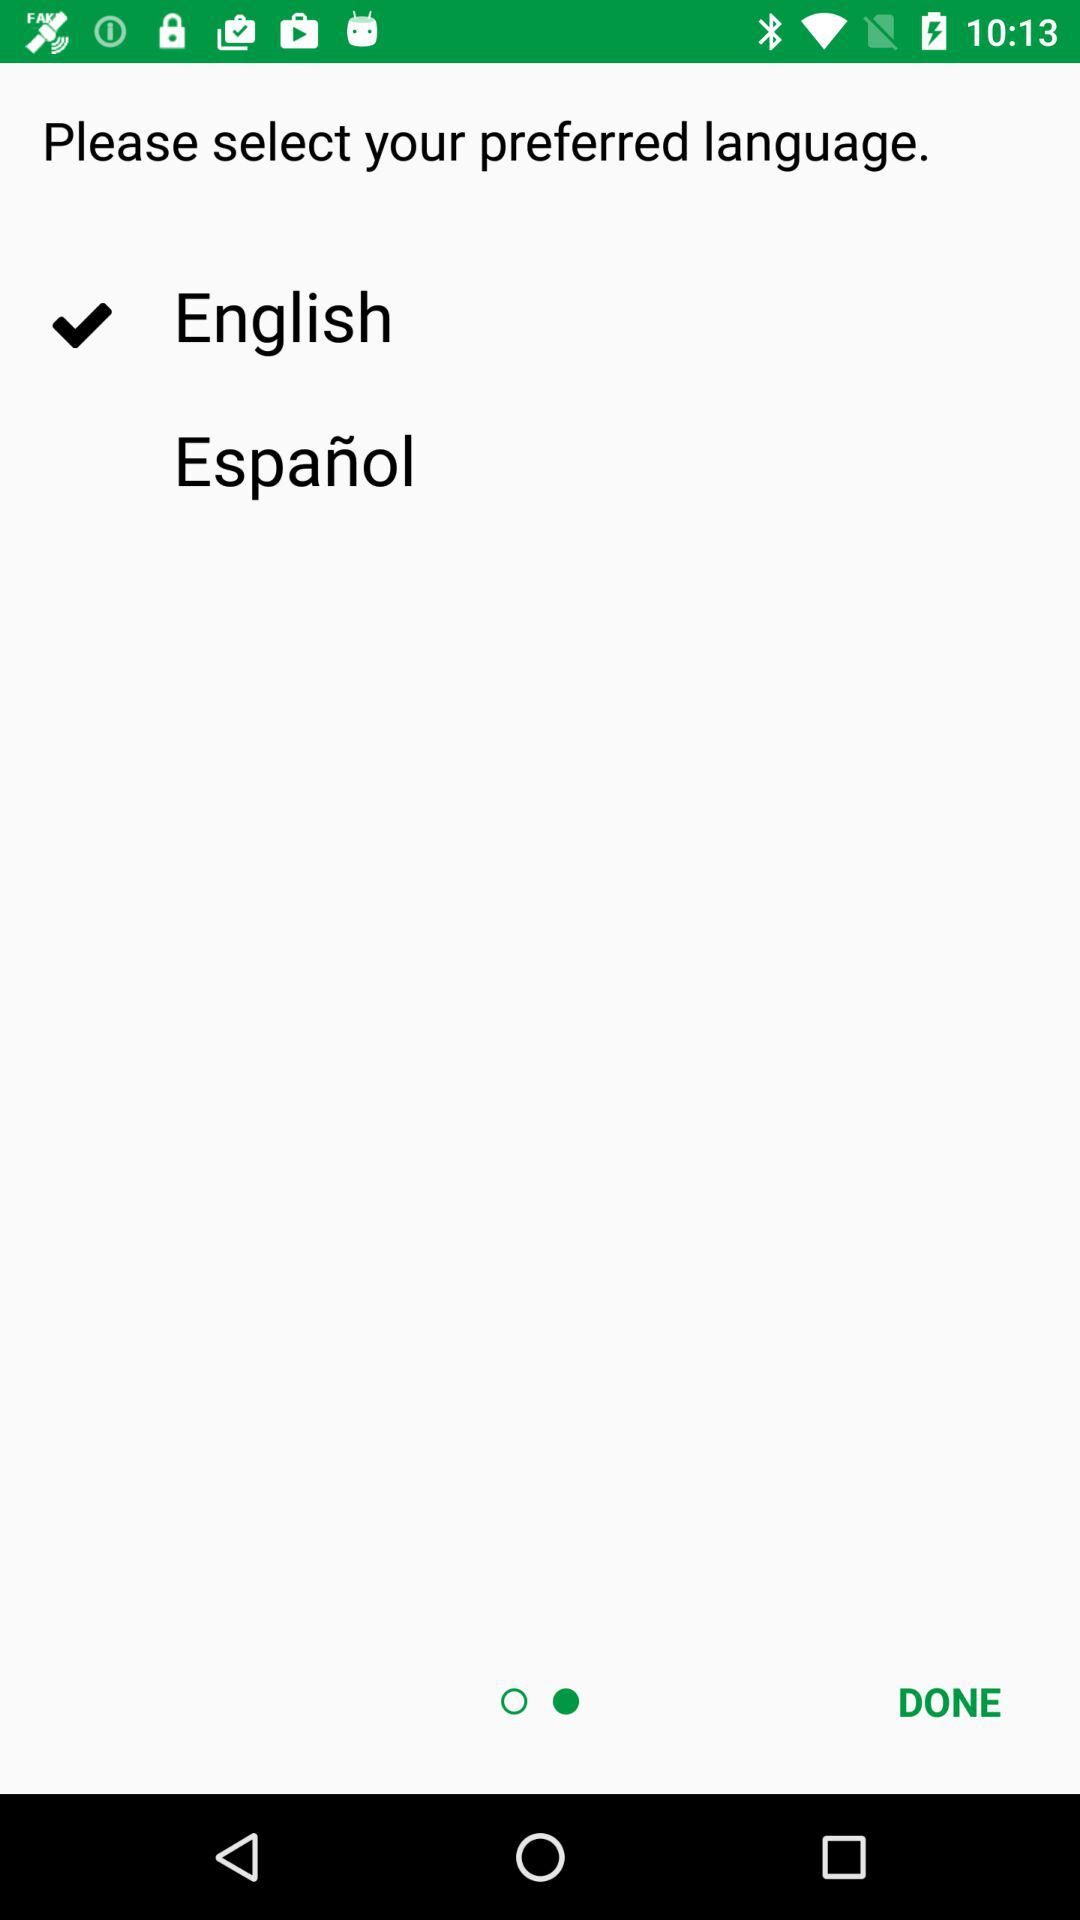Which language is selected? The selected language is "English". 